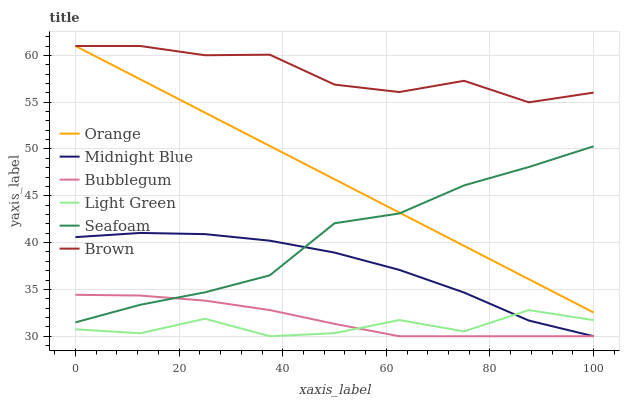Does Light Green have the minimum area under the curve?
Answer yes or no. Yes. Does Brown have the maximum area under the curve?
Answer yes or no. Yes. Does Midnight Blue have the minimum area under the curve?
Answer yes or no. No. Does Midnight Blue have the maximum area under the curve?
Answer yes or no. No. Is Orange the smoothest?
Answer yes or no. Yes. Is Light Green the roughest?
Answer yes or no. Yes. Is Midnight Blue the smoothest?
Answer yes or no. No. Is Midnight Blue the roughest?
Answer yes or no. No. Does Midnight Blue have the lowest value?
Answer yes or no. Yes. Does Seafoam have the lowest value?
Answer yes or no. No. Does Orange have the highest value?
Answer yes or no. Yes. Does Midnight Blue have the highest value?
Answer yes or no. No. Is Midnight Blue less than Orange?
Answer yes or no. Yes. Is Brown greater than Light Green?
Answer yes or no. Yes. Does Orange intersect Seafoam?
Answer yes or no. Yes. Is Orange less than Seafoam?
Answer yes or no. No. Is Orange greater than Seafoam?
Answer yes or no. No. Does Midnight Blue intersect Orange?
Answer yes or no. No. 